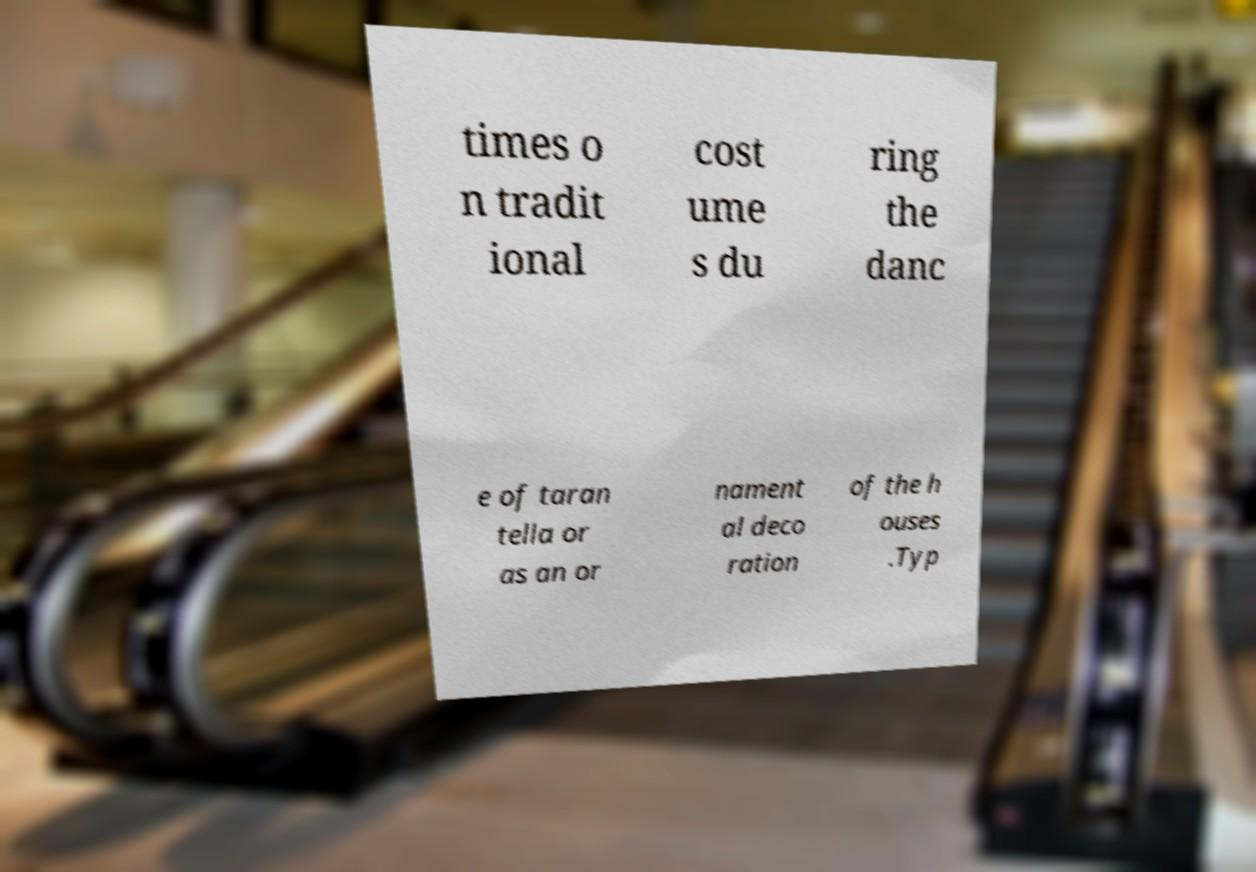Could you extract and type out the text from this image? times o n tradit ional cost ume s du ring the danc e of taran tella or as an or nament al deco ration of the h ouses .Typ 